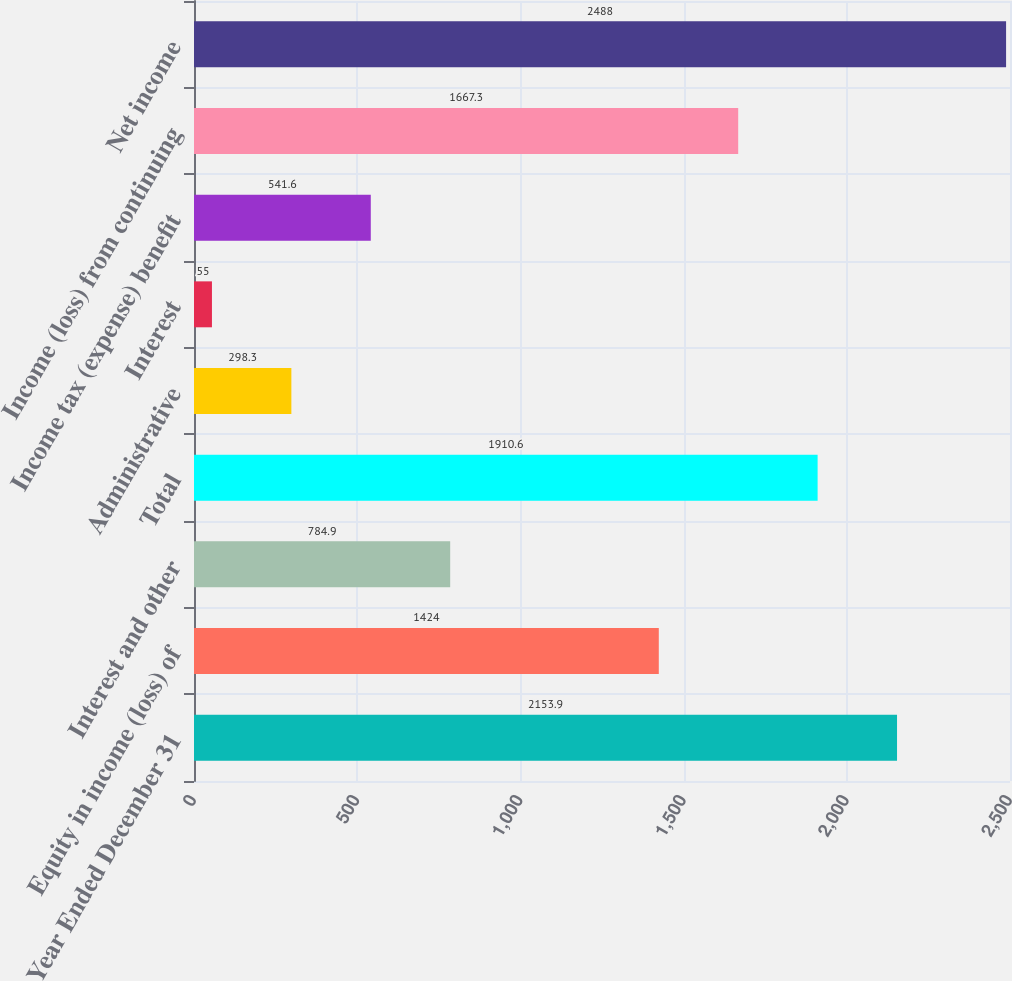Convert chart to OTSL. <chart><loc_0><loc_0><loc_500><loc_500><bar_chart><fcel>Year Ended December 31<fcel>Equity in income (loss) of<fcel>Interest and other<fcel>Total<fcel>Administrative<fcel>Interest<fcel>Income tax (expense) benefit<fcel>Income (loss) from continuing<fcel>Net income<nl><fcel>2153.9<fcel>1424<fcel>784.9<fcel>1910.6<fcel>298.3<fcel>55<fcel>541.6<fcel>1667.3<fcel>2488<nl></chart> 